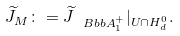Convert formula to latex. <formula><loc_0><loc_0><loc_500><loc_500>\widetilde { J } _ { M } \colon = \widetilde { J } _ { { \ B b b A } _ { 1 } ^ { + } } | _ { U \cap H _ { d } ^ { 0 } } .</formula> 